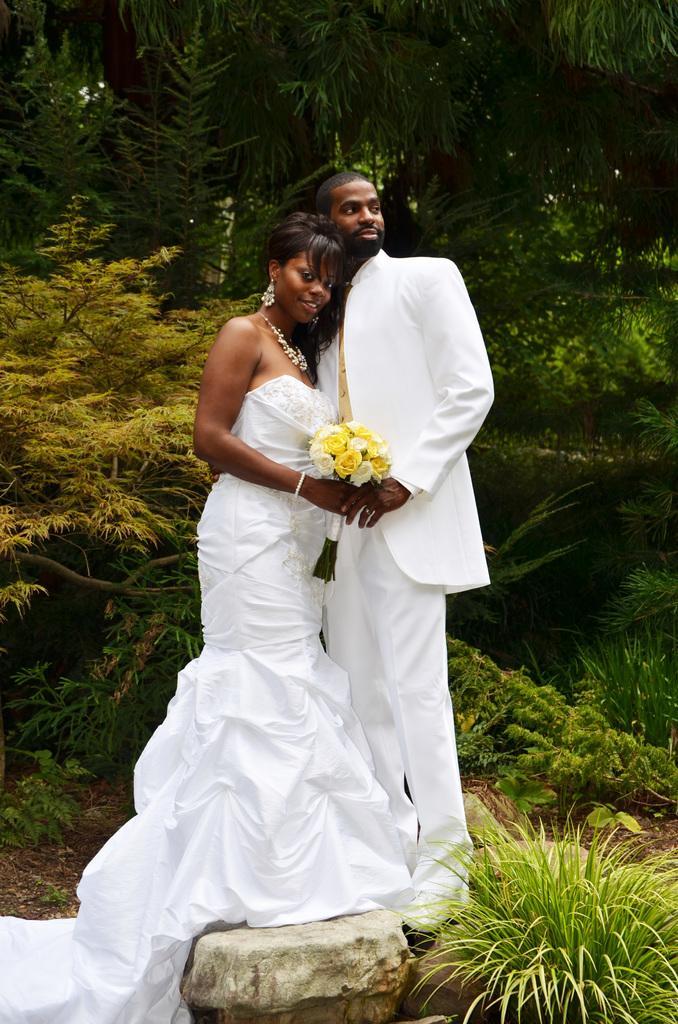How would you summarize this image in a sentence or two? This image consists of two persons wearing white dress. They are holding a bouquet. At the bottom, there is a rock. In the background, there are trees and plants. 